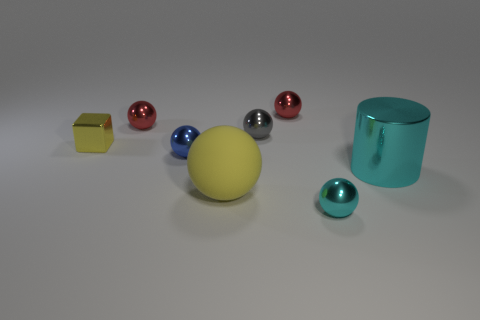Subtract all tiny shiny balls. How many balls are left? 1 Subtract all blue spheres. How many spheres are left? 5 Add 2 large yellow spheres. How many objects exist? 10 Subtract all purple spheres. Subtract all red blocks. How many spheres are left? 6 Subtract all cubes. How many objects are left? 7 Subtract all tiny yellow metallic cubes. Subtract all cylinders. How many objects are left? 6 Add 3 cyan cylinders. How many cyan cylinders are left? 4 Add 5 gray metallic things. How many gray metallic things exist? 6 Subtract 0 purple cubes. How many objects are left? 8 